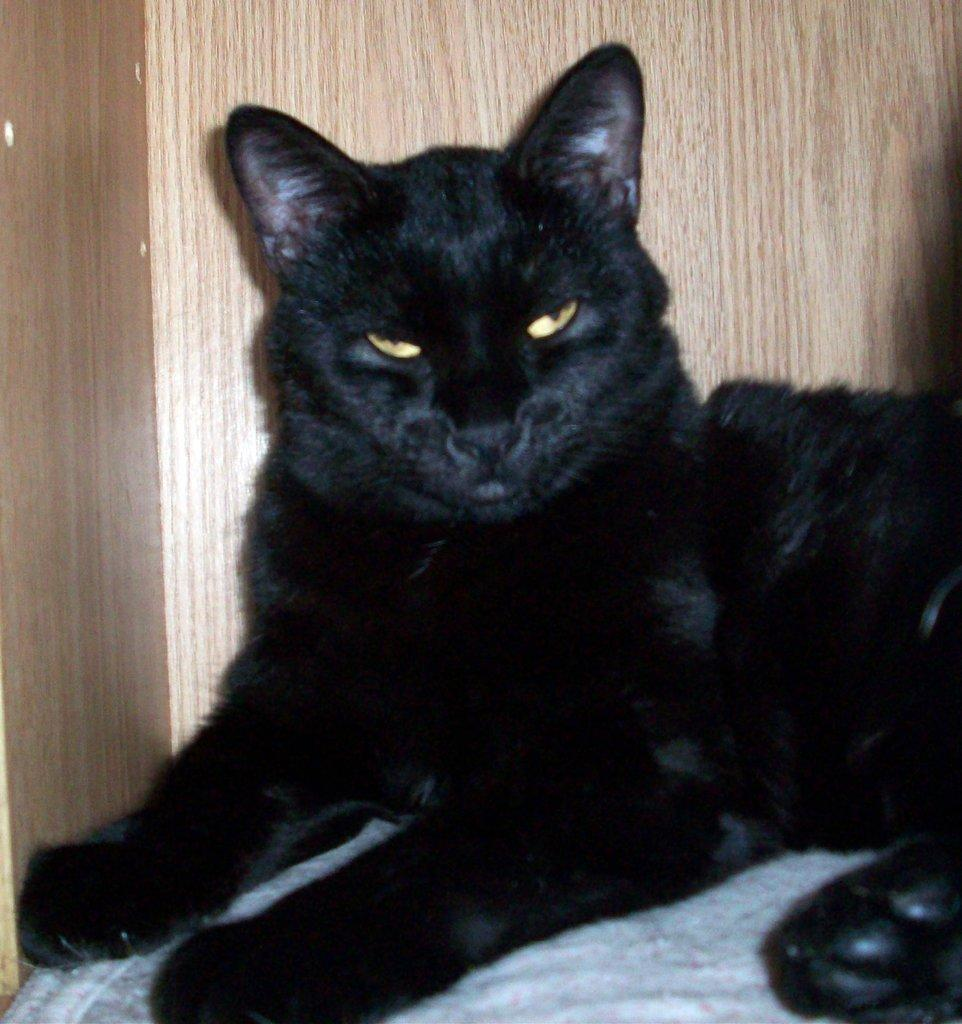What type of animal is in the image? There is a black color cat in the image. What is the cat doing in the image? The cat is sitting on a surface. What can be seen in the background of the image? There is a wooden wall in the background of the image. Is the cat resting its knee on the surface in the image? There is no mention of a knee in the image, as it features a cat sitting on a surface. 